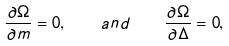Convert formula to latex. <formula><loc_0><loc_0><loc_500><loc_500>\frac { \partial \Omega } { \partial m } = 0 , \quad a n d \quad \frac { \partial \Omega } { \partial \Delta } = 0 ,</formula> 